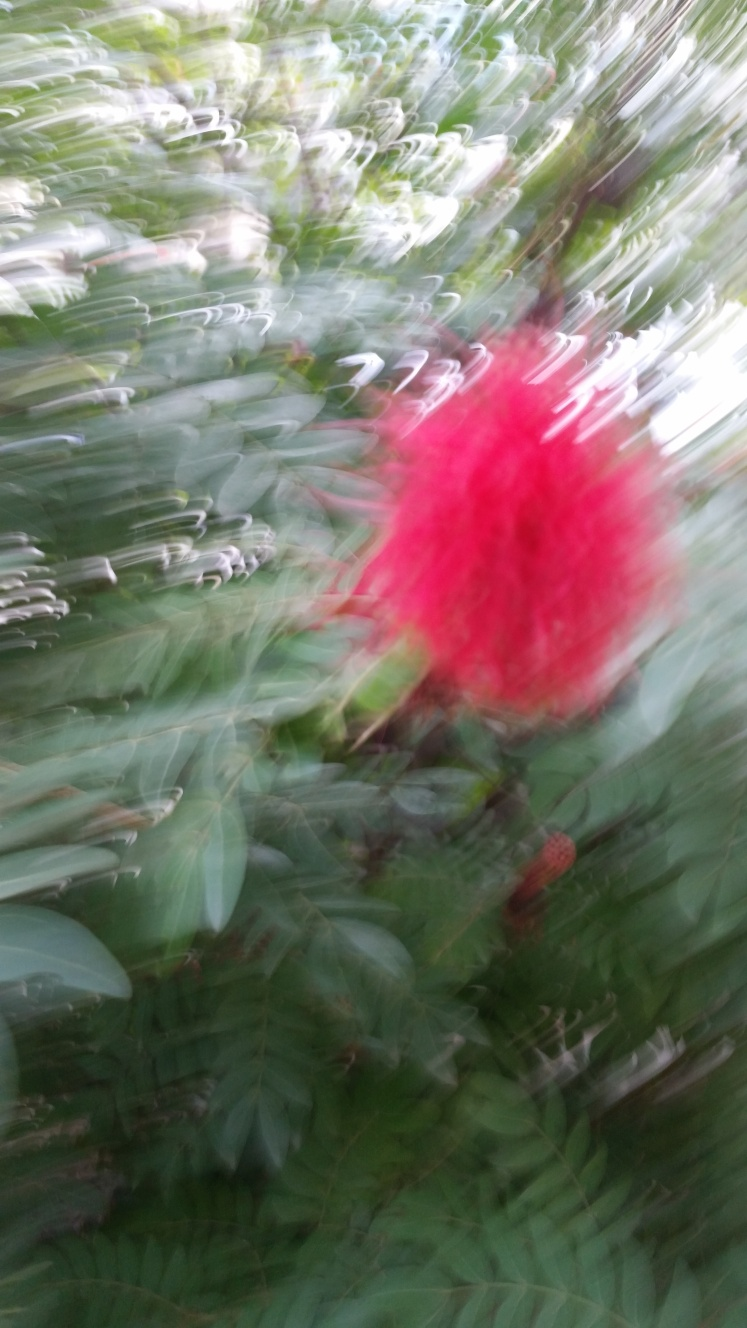How are the texture and details of the photographed subject?
A. Clear and well-defined
B. Enhanced
C. Almost completely lost
D. Partially visible
Answer with the option's letter from the given choices directly. The texture and details of the subject in the photograph appear to be option C, almost completely lost. This is likely due to motion blur, where the camera or subject moved during the shot, causing a smeared or streaked appearance and making it difficult to identify fine details. 